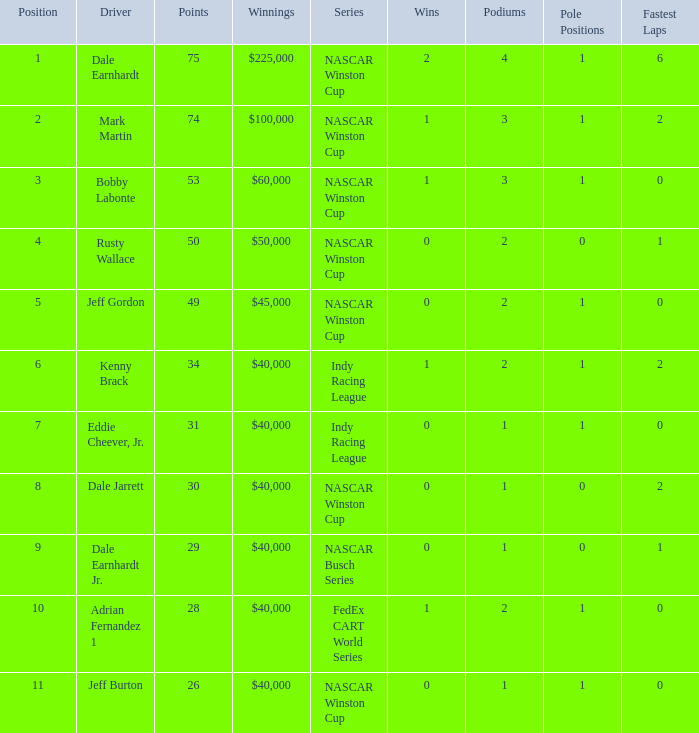In what position was the driver who won $60,000? 3.0. 